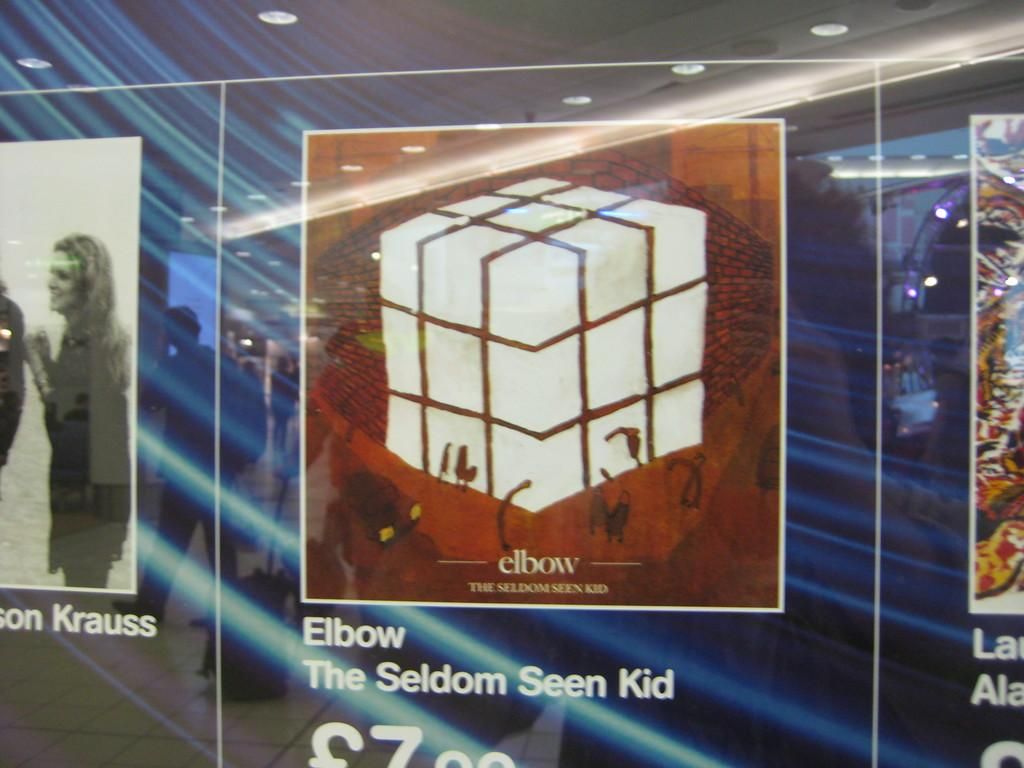Provide a one-sentence caption for the provided image. A listing for Elbow by the seldom seen kid with its price being 7.99. 